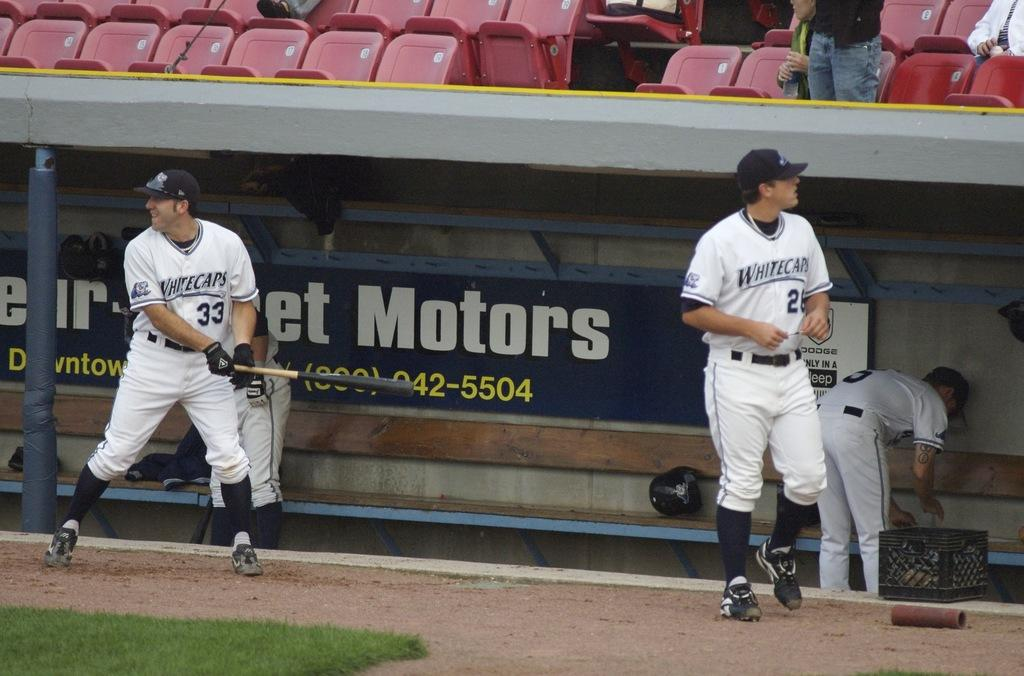<image>
Offer a succinct explanation of the picture presented. Several players from the Whitecaps baseball team are near their dugout. 